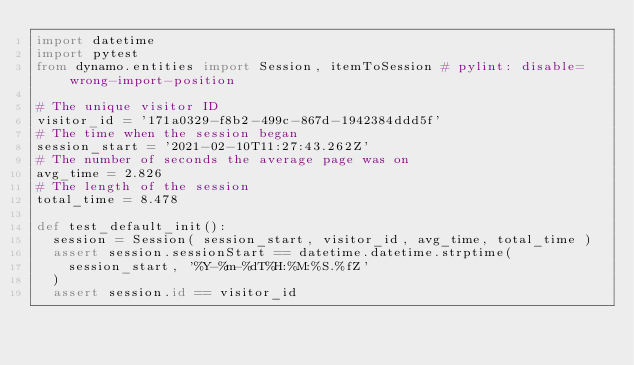Convert code to text. <code><loc_0><loc_0><loc_500><loc_500><_Python_>import datetime
import pytest
from dynamo.entities import Session, itemToSession # pylint: disable=wrong-import-position

# The unique visitor ID
visitor_id = '171a0329-f8b2-499c-867d-1942384ddd5f'
# The time when the session began
session_start = '2021-02-10T11:27:43.262Z'
# The number of seconds the average page was on
avg_time = 2.826
# The length of the session
total_time = 8.478

def test_default_init():
  session = Session( session_start, visitor_id, avg_time, total_time )
  assert session.sessionStart == datetime.datetime.strptime(
    session_start, '%Y-%m-%dT%H:%M:%S.%fZ'
  )
  assert session.id == visitor_id</code> 